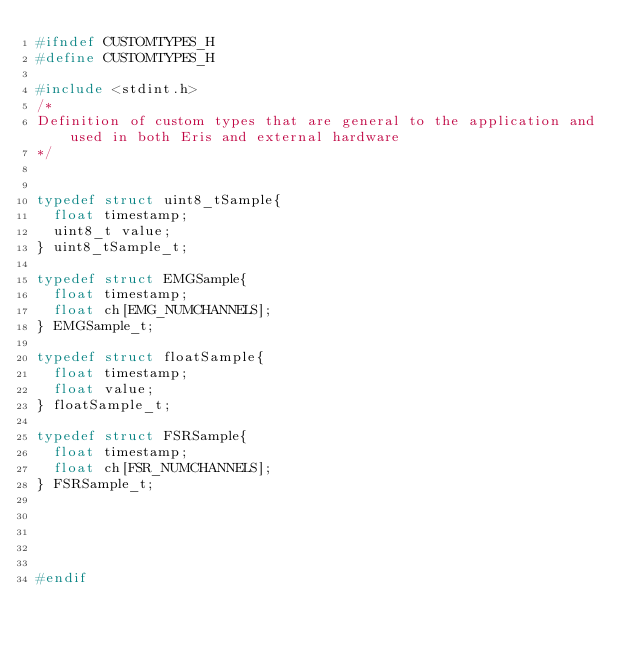<code> <loc_0><loc_0><loc_500><loc_500><_C_>#ifndef CUSTOMTYPES_H
#define CUSTOMTYPES_H

#include <stdint.h>
/* 
Definition of custom types that are general to the application and used in both Eris and external hardware
*/


typedef struct uint8_tSample{
  float timestamp;
  uint8_t value;  
} uint8_tSample_t;

typedef struct EMGSample{
  float timestamp;
  float ch[EMG_NUMCHANNELS];  
} EMGSample_t;

typedef struct floatSample{
  float timestamp;
  float value;  
} floatSample_t;

typedef struct FSRSample{
  float timestamp;
  float ch[FSR_NUMCHANNELS];   
} FSRSample_t;
 




#endif
</code> 